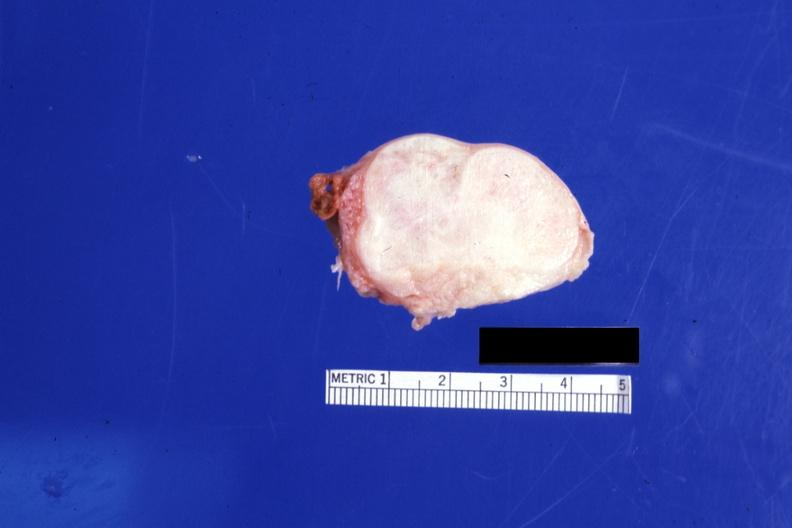what is present?
Answer the question using a single word or phrase. Female reproductive 